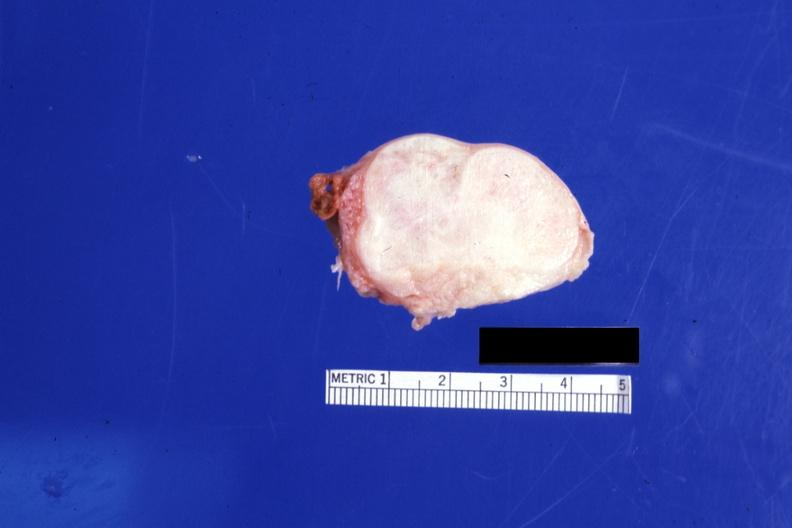what is present?
Answer the question using a single word or phrase. Female reproductive 